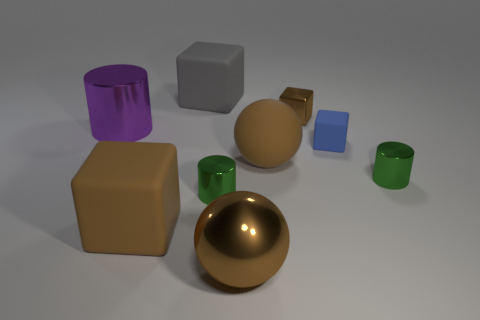Subtract all rubber cubes. How many cubes are left? 1 Subtract 2 blocks. How many blocks are left? 2 Subtract all red blocks. Subtract all gray cylinders. How many blocks are left? 4 Subtract all cubes. How many objects are left? 5 Subtract 0 green cubes. How many objects are left? 9 Subtract all shiny blocks. Subtract all green cylinders. How many objects are left? 6 Add 9 purple things. How many purple things are left? 10 Add 7 small green cylinders. How many small green cylinders exist? 9 